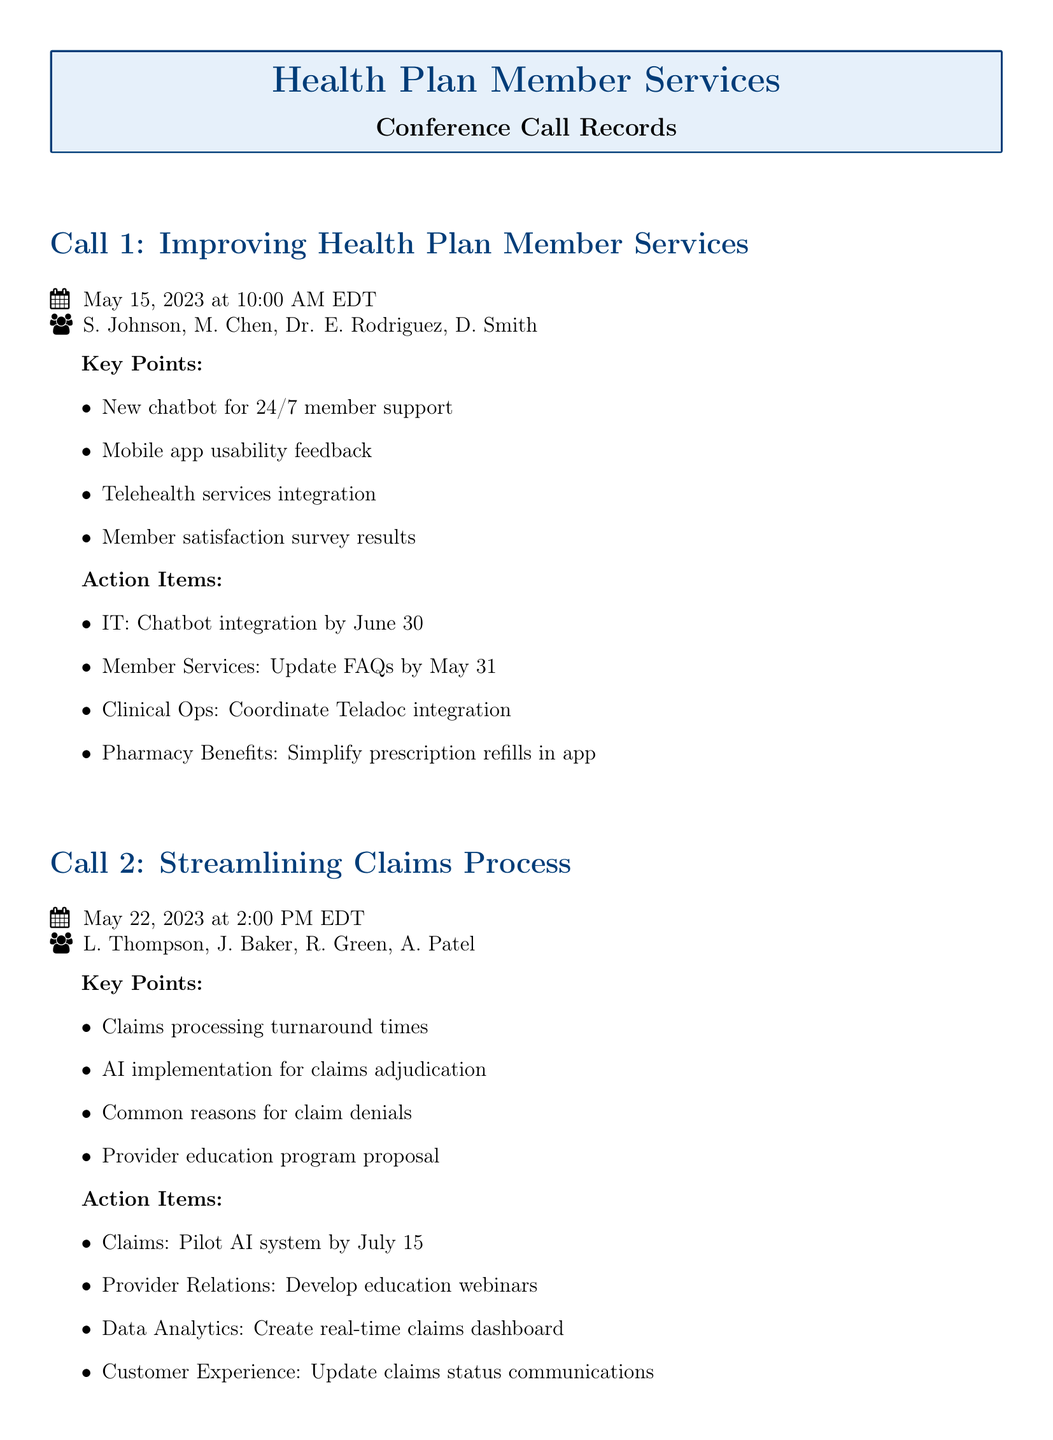what date was the first call held? The first call was held on May 15, 2023.
Answer: May 15, 2023 who were the participants in the second call? The participants in the second call were L. Thompson, J. Baker, R. Green, and A. Patel.
Answer: L. Thompson, J. Baker, R. Green, A. Patel what is one key point discussed in the first call? One key point discussed in the first call was the new chatbot for 24/7 member support.
Answer: new chatbot for 24/7 member support what is the deadline for the IT action item from the first call? The IT action item related to chatbot integration has a deadline of June 30.
Answer: June 30 how many action items were listed in the second call? There were four action items listed in the second call.
Answer: four what topic was addressed in the second call? The topic addressed in the second call was streamlining the claims process.
Answer: streamlining claims process what is one reason for claim denials mentioned in the second call? One common reason for claim denials mentioned was related to claims processing turnaround times.
Answer: claims processing turnaround times who is responsible for updating FAQs according to the first call? The Member Services team is responsible for updating FAQs.
Answer: Member Services what specific member service is the Clinical Ops team coordinating? The Clinical Ops team is coordinating Teladoc integration.
Answer: Teladoc integration 